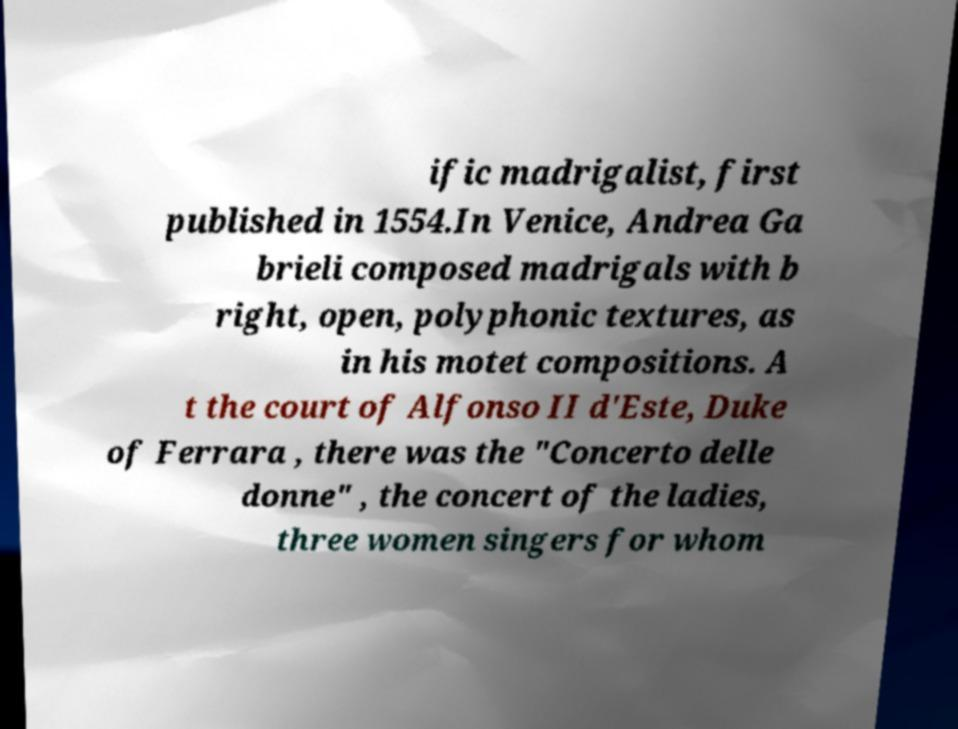Can you read and provide the text displayed in the image?This photo seems to have some interesting text. Can you extract and type it out for me? ific madrigalist, first published in 1554.In Venice, Andrea Ga brieli composed madrigals with b right, open, polyphonic textures, as in his motet compositions. A t the court of Alfonso II d'Este, Duke of Ferrara , there was the "Concerto delle donne" , the concert of the ladies, three women singers for whom 